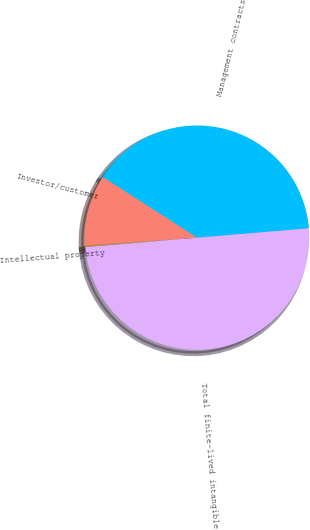Convert chart. <chart><loc_0><loc_0><loc_500><loc_500><pie_chart><fcel>Management contracts<fcel>Investor/customer<fcel>Intellectual property<fcel>Total finite-lived intangible<nl><fcel>39.57%<fcel>10.19%<fcel>0.24%<fcel>50.0%<nl></chart> 